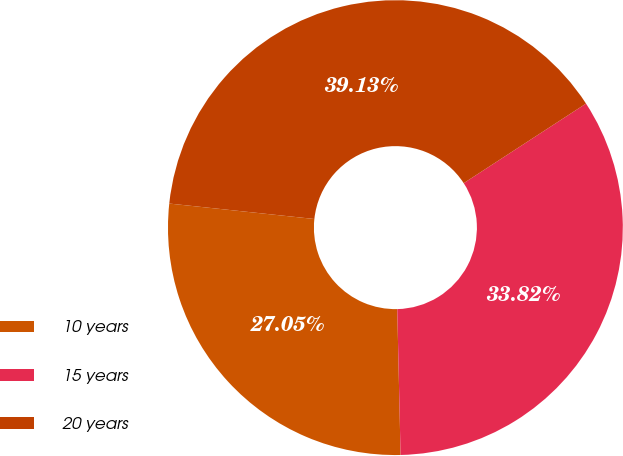Convert chart. <chart><loc_0><loc_0><loc_500><loc_500><pie_chart><fcel>10 years<fcel>15 years<fcel>20 years<nl><fcel>27.05%<fcel>33.82%<fcel>39.13%<nl></chart> 